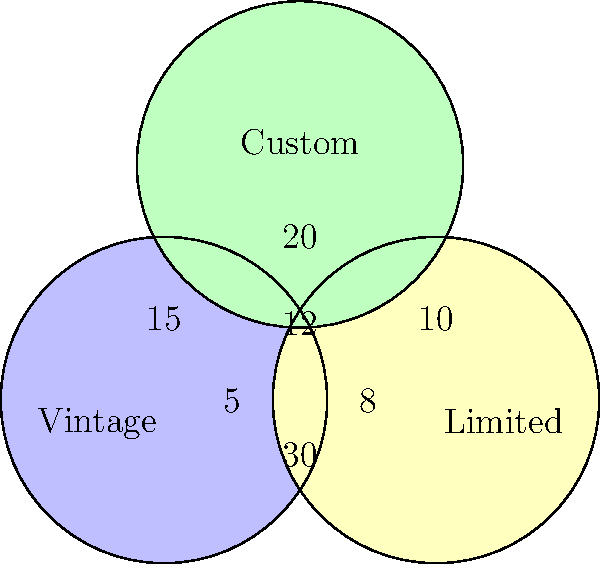In the Venn diagram above, three overlapping circles represent different Hector toy collector communities: Vintage, Limited Edition, and Custom. The numbers in each region indicate the number of collectors. How many collectors are interested in all three types of Hector toys? To find the number of collectors interested in all three types of Hector toys, we need to follow these steps:

1. Identify the region where all three circles overlap. This is the central area of the Venn diagram.

2. Look for the number in this central region. We can see that the number in the center is 12.

3. This number represents the collectors who are interested in Vintage, Limited Edition, and Custom Hector toys simultaneously.

4. Therefore, 12 collectors are interested in all three types of Hector toys.

This information is valuable for fellow collectors as it shows the core group of enthusiasts who are likely to have the most diverse knowledge and collection of Hector toys across all categories.
Answer: 12 